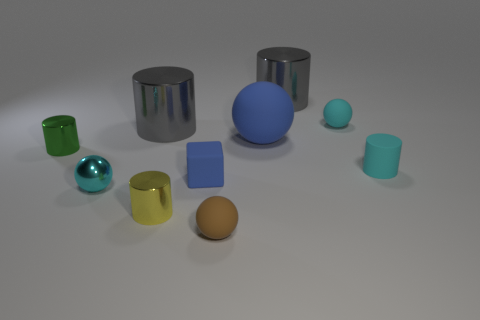The brown rubber thing that is the same shape as the big blue object is what size?
Your response must be concise. Small. There is a brown rubber thing; is it the same shape as the cyan rubber object in front of the tiny green object?
Give a very brief answer. No. What is the size of the cyan object on the right side of the tiny sphere that is behind the cyan metallic object?
Offer a very short reply. Small. Are there the same number of small matte cylinders that are on the left side of the matte cylinder and small cyan shiny objects to the left of the shiny sphere?
Make the answer very short. Yes. There is a shiny thing that is the same shape as the big blue matte object; what is its color?
Ensure brevity in your answer.  Cyan. What number of small metal objects have the same color as the metal ball?
Your response must be concise. 0. There is a cyan thing that is left of the small brown object; does it have the same shape as the brown thing?
Offer a very short reply. Yes. The cyan thing to the left of the metal cylinder in front of the metal object to the left of the cyan metal ball is what shape?
Ensure brevity in your answer.  Sphere. How big is the green thing?
Your response must be concise. Small. There is a tiny cylinder that is made of the same material as the green object; what is its color?
Ensure brevity in your answer.  Yellow. 